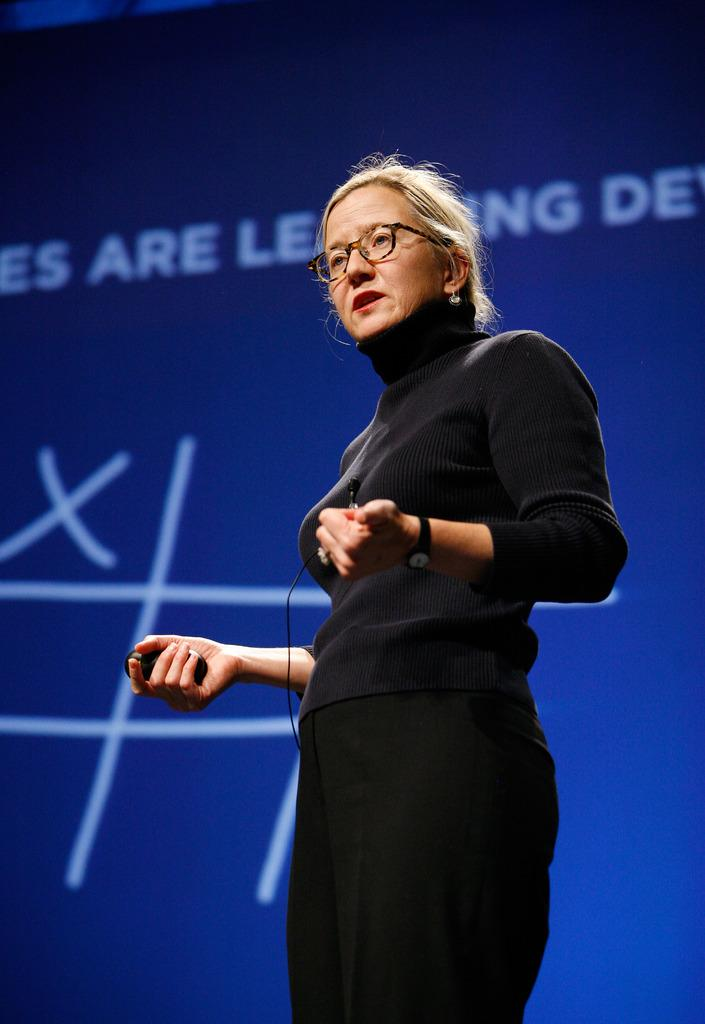Who is the main subject in the image? There is an old woman in the image. What is the old woman wearing? The old woman is wearing a black dress. Where is the old woman located in the image? The old woman is standing on a stage. What color is the banner in the background of the image? There is a blue banner in the background of the image. Can you tell me how many faucets are visible in the image? There are no faucets present in the image. What type of fear does the old woman express in the image? There is no indication of fear in the image; the old woman is simply standing on a stage. 